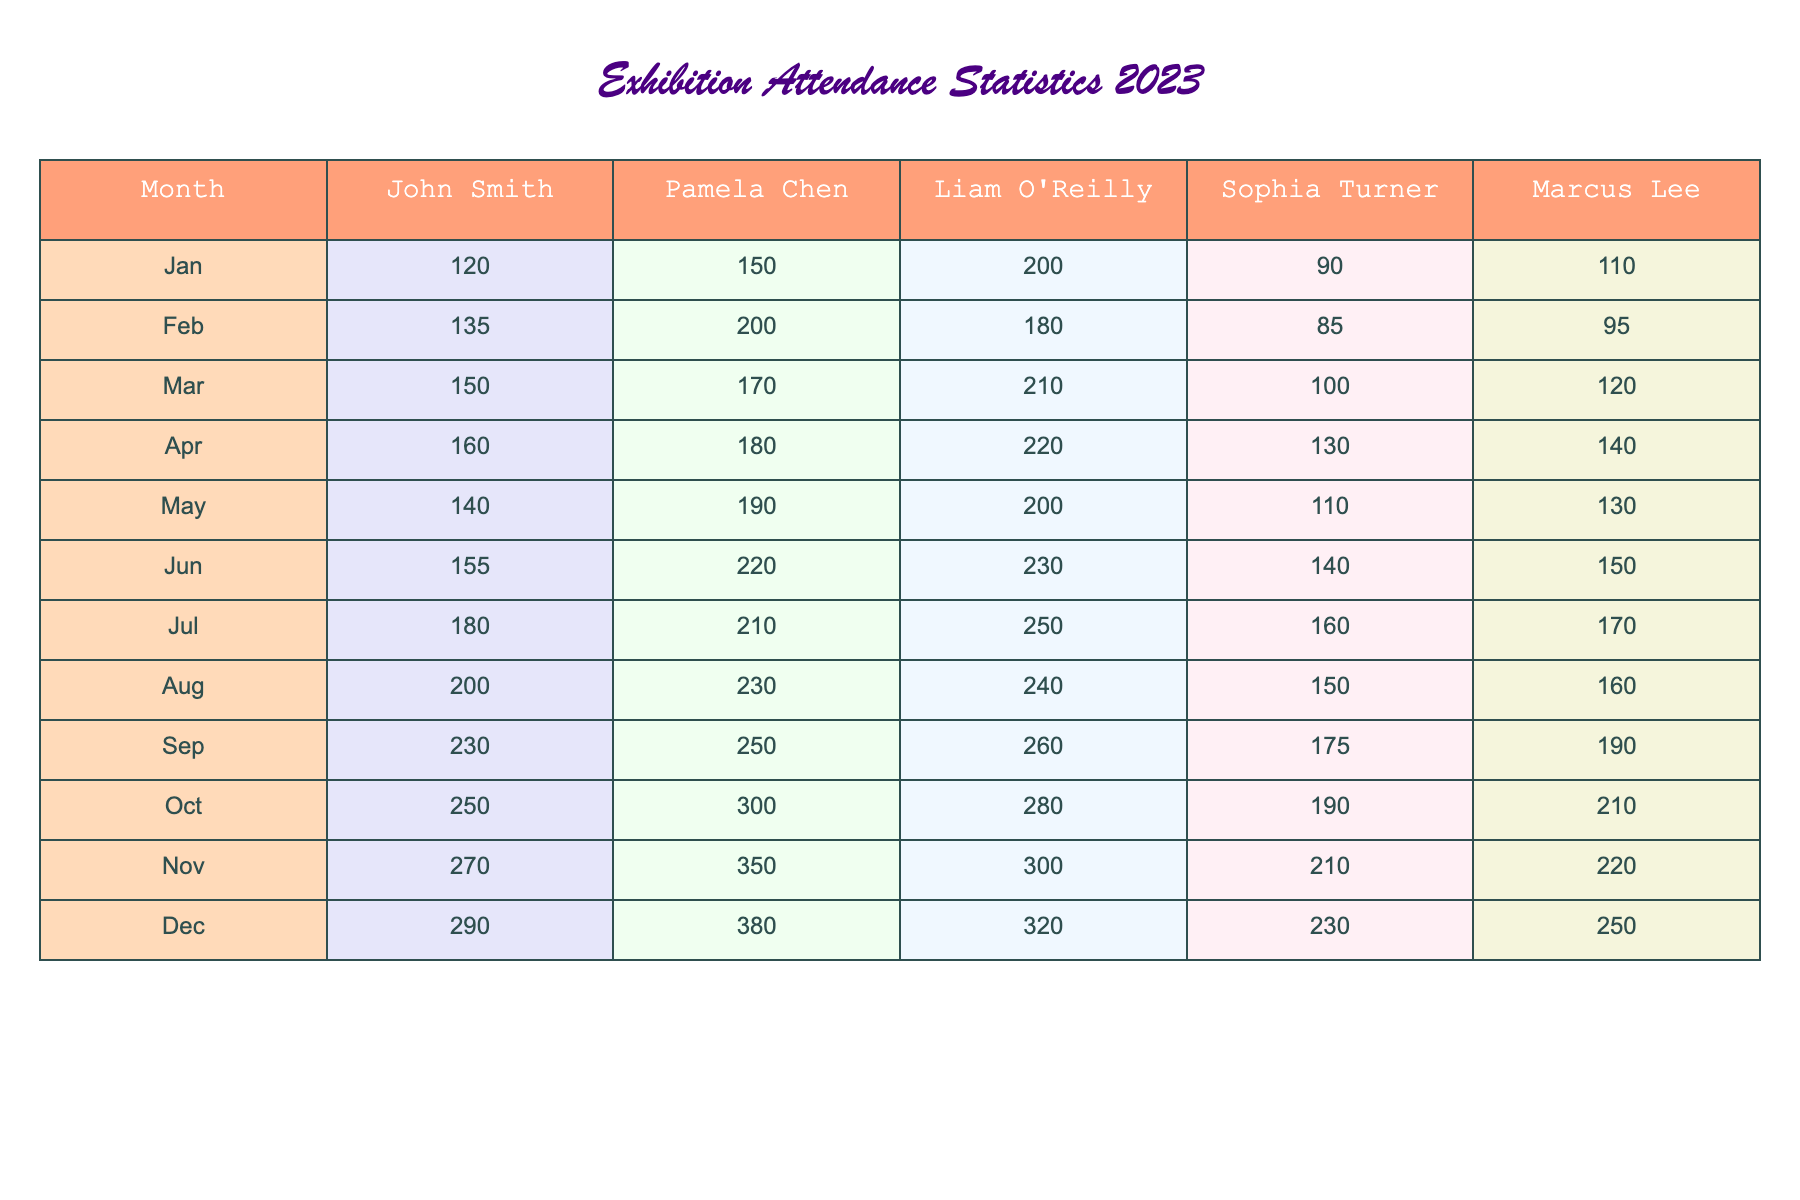What was the total attendance for Sophia Turner in December? The attendance for Sophia Turner in December is stated as 230 in the table. Thus, the total attendance for her in that month is 230.
Answer: 230 Which artist had the highest attendance in March? In March, the attendance figures are as follows: John Smith (150), Pamela Chen (170), Liam O'Reilly (210), Sophia Turner (100), and Marcus Lee (120). The highest figure is Liam O'Reilly with 210.
Answer: Liam O'Reilly What was the average attendance for Marcus Lee over the 12 months? To find the average attendance for Marcus Lee, sum the attendance figures for each month, which are 110, 95, 120, 140, 130, 150, 170, 160, 190, 210, and 250, giving a total of 1,800. Then, divide by 12 months: 1,800/12 = 150.
Answer: 150 Did John Smith have more than 250 attendees in any month? By examining the month-by-month data for John Smith, the highest recorded attendance is 290 in December, which is greater than 250. Therefore, yes, he had more than 250 attendees in that month.
Answer: Yes What is the percentage increase in attendance for Pamela Chen from January to November? First, find the attendance in January (150) and in November (350). The increase is 350 - 150 = 200. Next, to calculate the percentage increase: (200/150) * 100 = 133.33%.
Answer: 133.33% Which month had the lowest overall attendance and what was the figure? To find the lowest overall attendance, sum the attendance for each month. The totals are as follows: January (670), February (610), March (780), April (810), May (770), June (850), July (970), August (980), September (965), October (1010), November (1180), and December (1290). The lowest total is in February with 610.
Answer: February, 610 Who had the most consistent attendance throughout the months? To determine consistency, look at the differences in attendance across the months for each artist. John Smith fluctuates but shows a general increase, but Pamela Chen has varying numbers, as does the rest. Checking standard deviation can show this; however, from visual inspection, John Smith has the smallest range. Thus he appears the most consistent.
Answer: John Smith What is the total attendance for all artists combined in the month of July? We sum the attendance for all artists in July: John Smith (180), Pamela Chen (210), Liam O'Reilly (250), Sophia Turner (160), and Marcus Lee (170). The total is 180 + 210 + 250 + 160 + 170 = 1070.
Answer: 1070 Which artist's attendance shows the highest increase from January to December? For each artist, subtract their January attendance from their December attendance: John Smith (290 - 120 = 170), Pamela Chen (380 - 150 = 230), Liam O'Reilly (320 - 200 = 120), Sophia Turner (230 - 90 = 140), and Marcus Lee (250 - 110 = 140). The highest increase is for Pamela Chen at 230.
Answer: Pamela Chen What was the least amount of attendance for Liam O'Reilly throughout the year? Looking through the attendance numbers for Liam O'Reilly, we see that the lowest attendance is in January at 200.
Answer: 200 